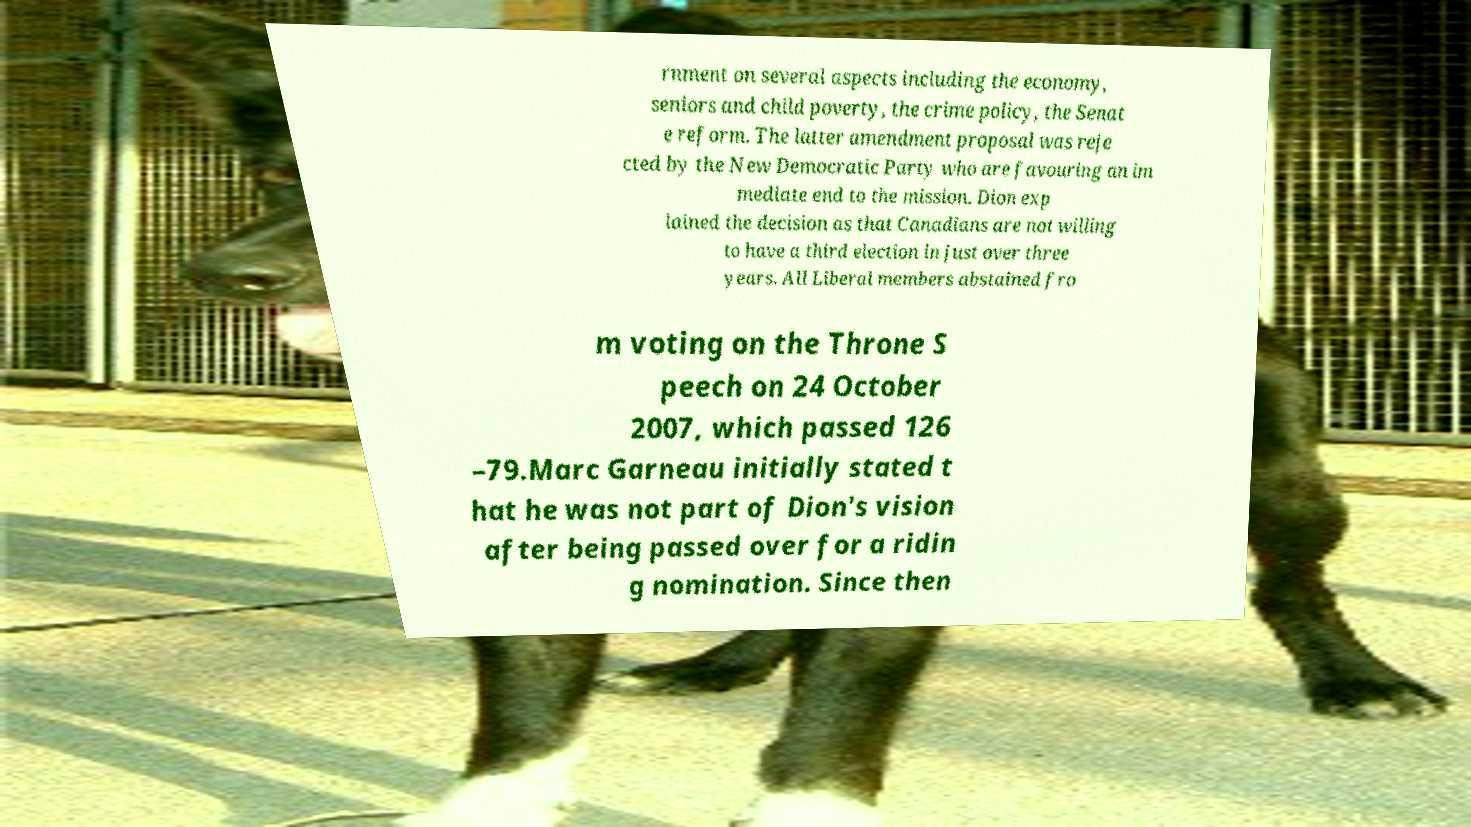Can you read and provide the text displayed in the image?This photo seems to have some interesting text. Can you extract and type it out for me? rnment on several aspects including the economy, seniors and child poverty, the crime policy, the Senat e reform. The latter amendment proposal was reje cted by the New Democratic Party who are favouring an im mediate end to the mission. Dion exp lained the decision as that Canadians are not willing to have a third election in just over three years. All Liberal members abstained fro m voting on the Throne S peech on 24 October 2007, which passed 126 –79.Marc Garneau initially stated t hat he was not part of Dion's vision after being passed over for a ridin g nomination. Since then 